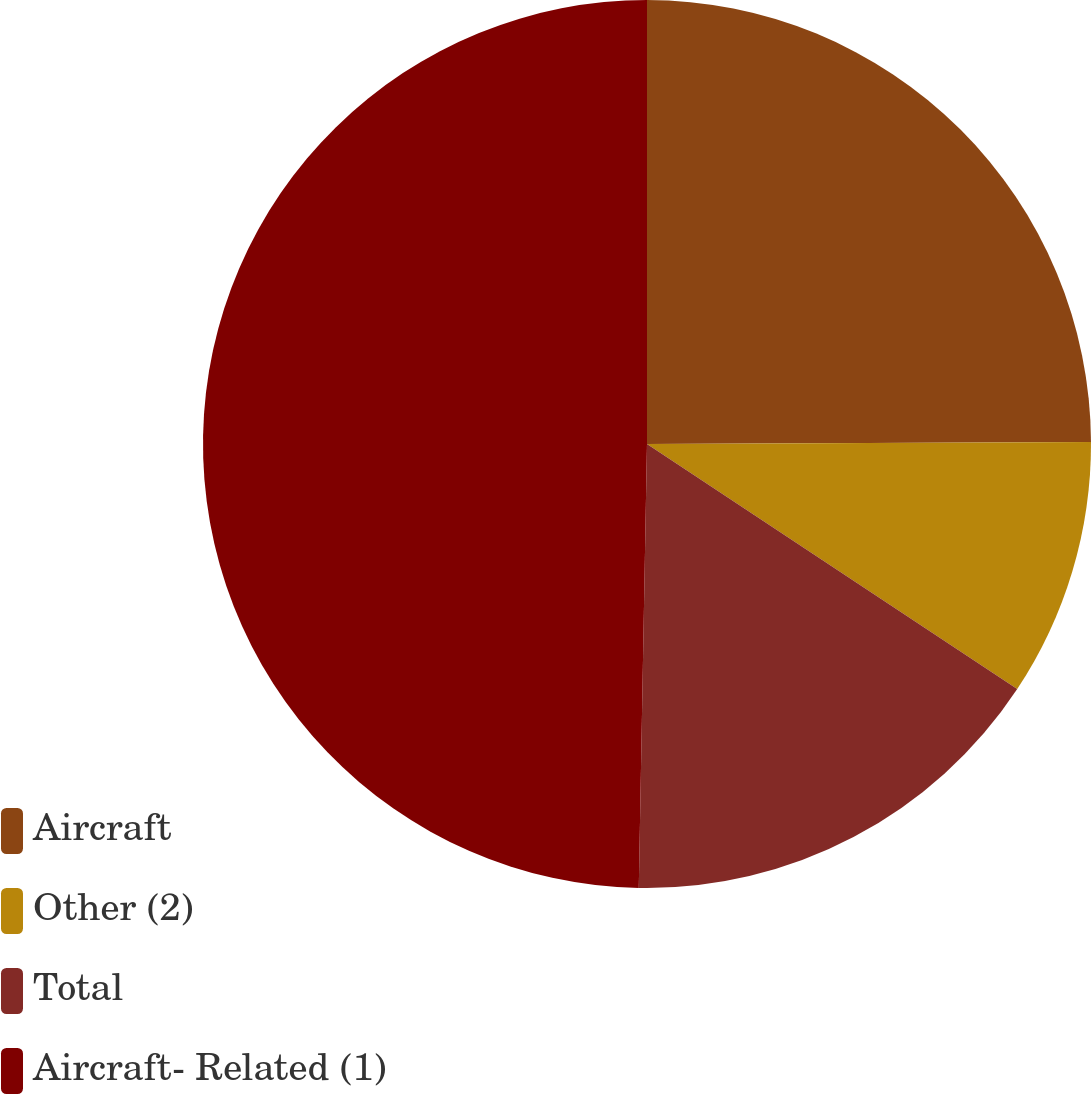Convert chart. <chart><loc_0><loc_0><loc_500><loc_500><pie_chart><fcel>Aircraft<fcel>Other (2)<fcel>Total<fcel>Aircraft- Related (1)<nl><fcel>24.93%<fcel>9.38%<fcel>15.99%<fcel>49.71%<nl></chart> 